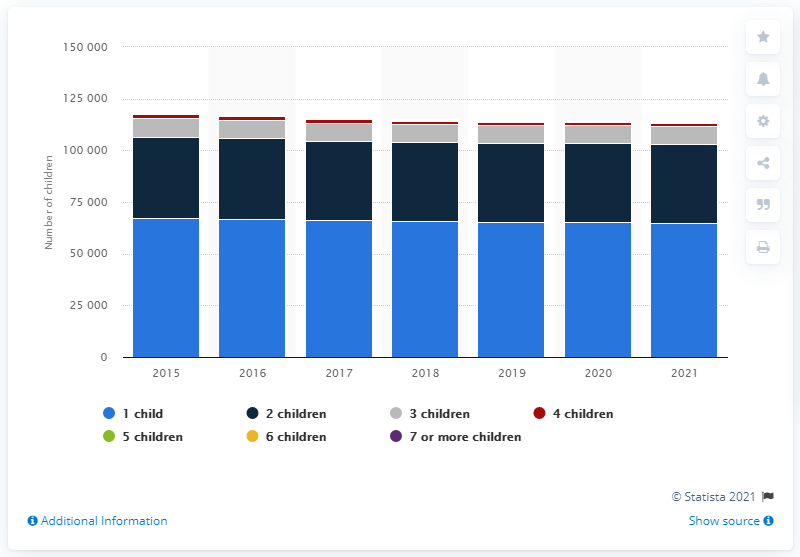Indicate a few pertinent items in this graphic. According to the data, there were 34 Danish women who were single mothers and had seven or more children. The number of single mothers in Denmark decreased slightly in 2021. There were 64,948 single mothers in Denmark in 2021. 